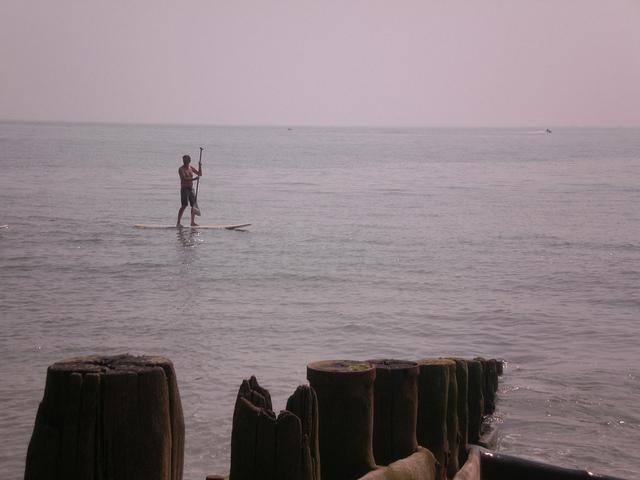How many people are in the photo?
Give a very brief answer. 1. How many birds are flying?
Give a very brief answer. 0. How many windows are on the train in the picture?
Give a very brief answer. 0. 